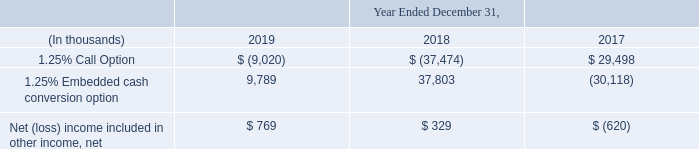1.25% Notes Embedded Cash Conversion Option
The embedded cash conversion option within the 1.25% Notes is required to be separated from the 1.25% Notes and accounted for separately as a derivative liability, with changes in fair value recognized immediately in our consolidated statements of operations in Other income (loss), net until the cash conversion option settles or expires.
The initial fair value liability of the embedded cash conversion option was $82.8 million, which simultaneously reduced the carrying value of the 1.25% Notes (effectively an original issuance discount). The embedded cash conversion option is measured and reported at fair value on a recurring basis within Level 3 of the fair value hierarchy. For further discussion of the inputs used to determine the fair value of the embedded cash conversion option, refer to Note 1, “Basis of Presentation and Significant Accounting Policies.”
The following table shows the net impact of the changes in fair values of the 1.25% Call Option and 1.25% Notes embedded cash conversion option in the consolidated statements of operations:
What is the 1.25% Embedded cash conversion option value in 2019?
Answer scale should be: thousand. 9,789. What was the initial fair value liability of the embedded cash conversion option? $82.8 million. What was the value of 1.25% call option in 2019?
Answer scale should be: thousand. $ (9,020). What is the change in the value of 1.25% call option from 2018 to 2019?
Answer scale should be: thousand. -9,020 - (-37,474)
Answer: 28454. What is the average 1.25% Embedded cash conversion option between 2017-2019?
Answer scale should be: thousand. (9,789 + 37,803 - 30,118) / 3
Answer: 5824.67. What is the change in the Net (loss) income included in other income, net from 2018 to 2019?
Answer scale should be: thousand. 769 - 329
Answer: 440. 